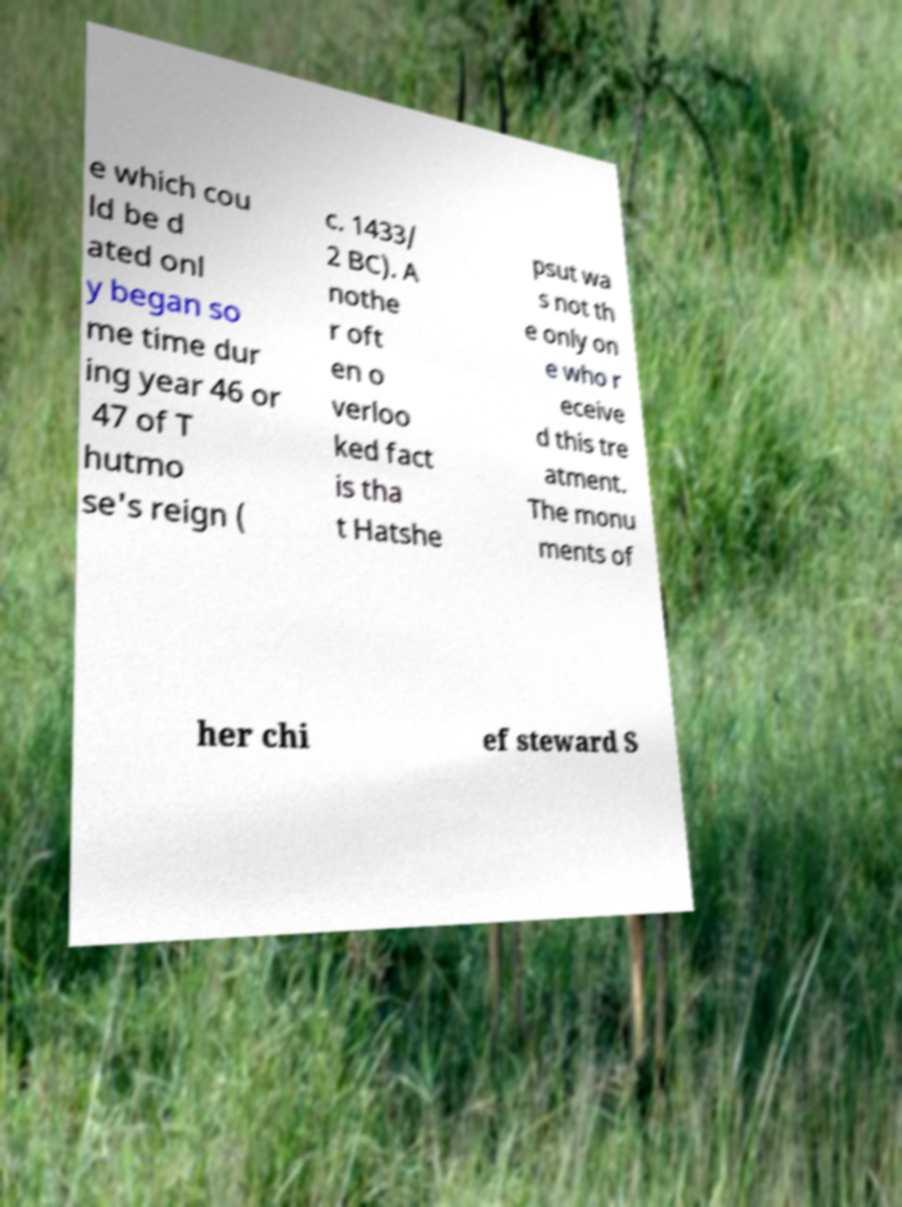Please identify and transcribe the text found in this image. e which cou ld be d ated onl y began so me time dur ing year 46 or 47 of T hutmo se's reign ( c. 1433/ 2 BC). A nothe r oft en o verloo ked fact is tha t Hatshe psut wa s not th e only on e who r eceive d this tre atment. The monu ments of her chi ef steward S 